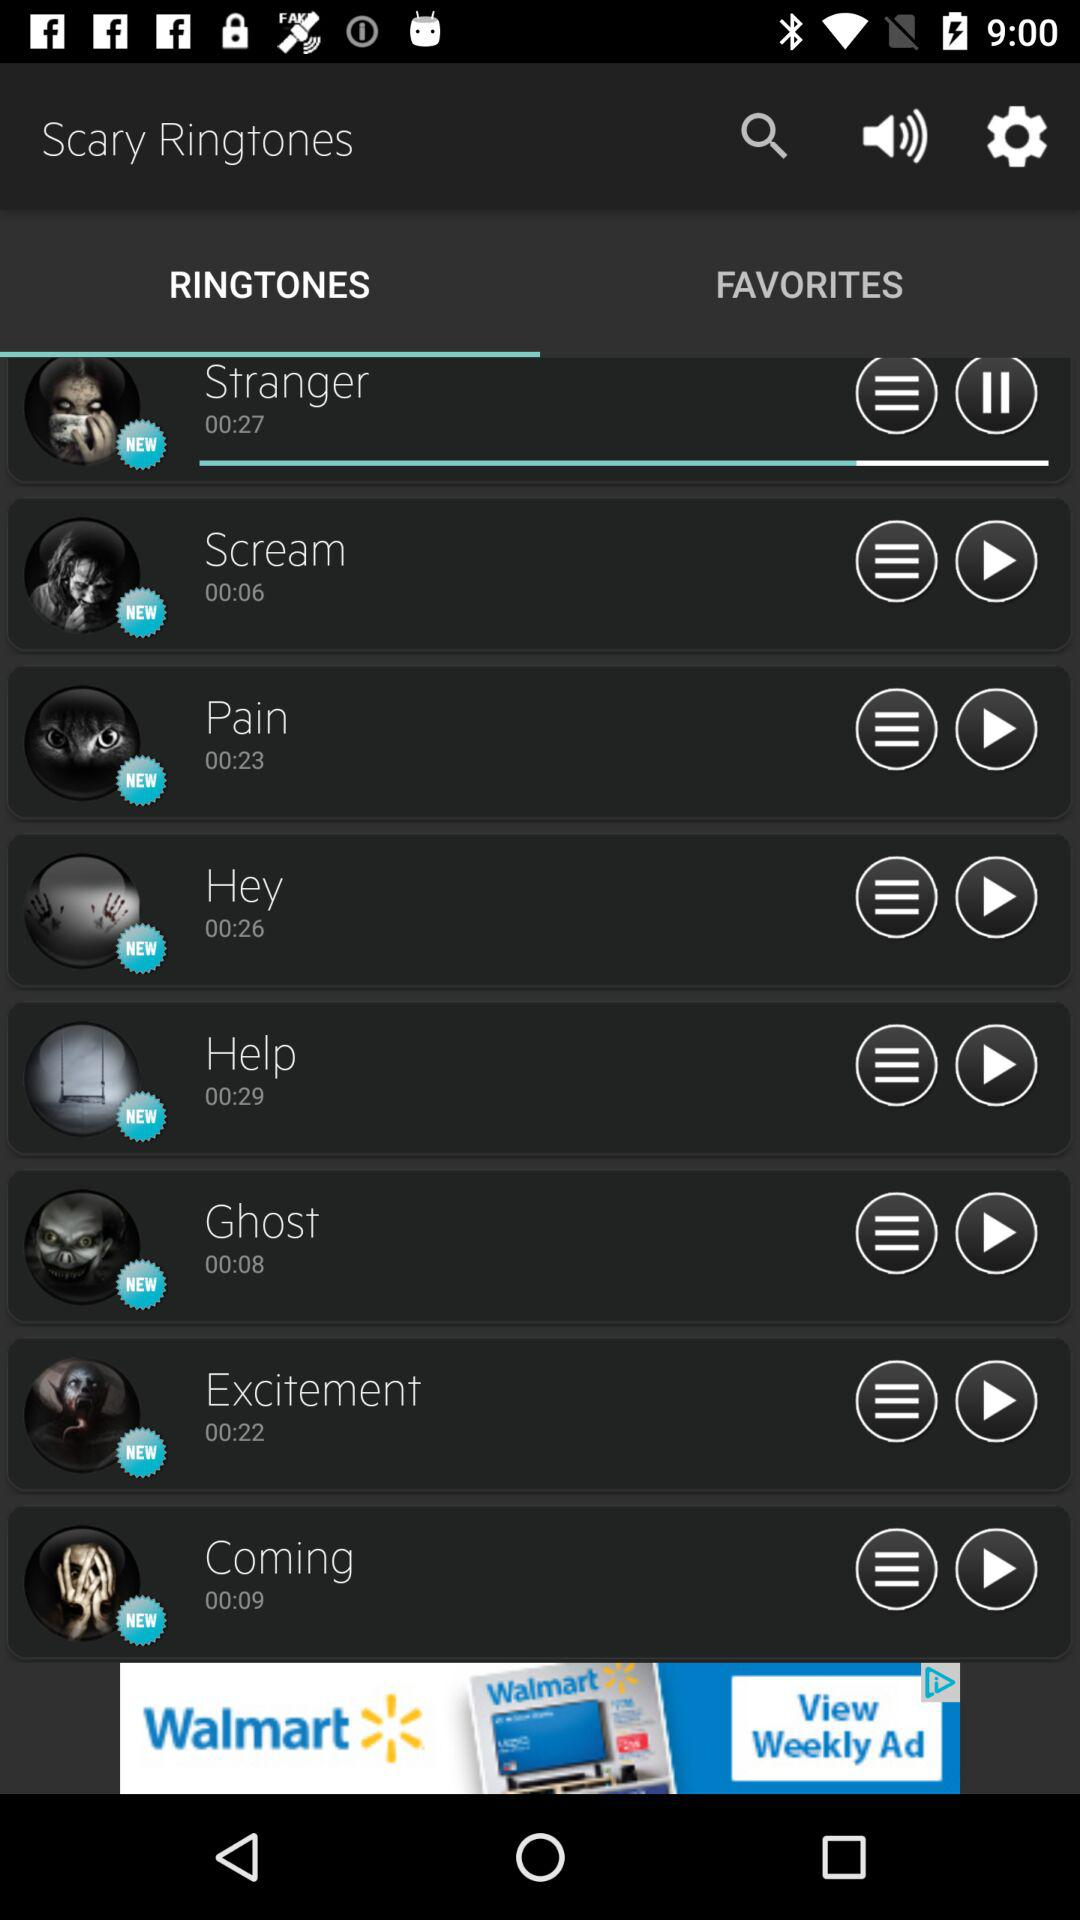What's the duration of "Coming"? The duration is 00:09 seconds. 